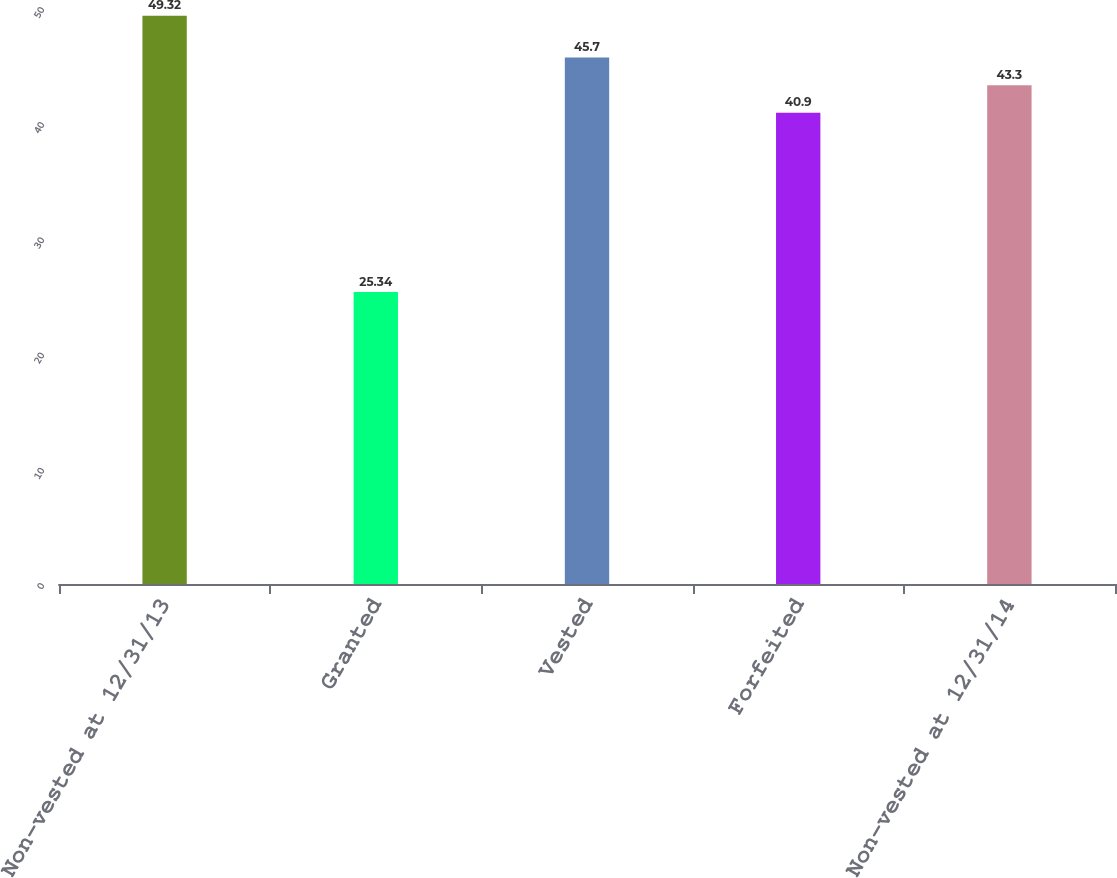Convert chart. <chart><loc_0><loc_0><loc_500><loc_500><bar_chart><fcel>Non-vested at 12/31/13<fcel>Granted<fcel>Vested<fcel>Forfeited<fcel>Non-vested at 12/31/14<nl><fcel>49.32<fcel>25.34<fcel>45.7<fcel>40.9<fcel>43.3<nl></chart> 